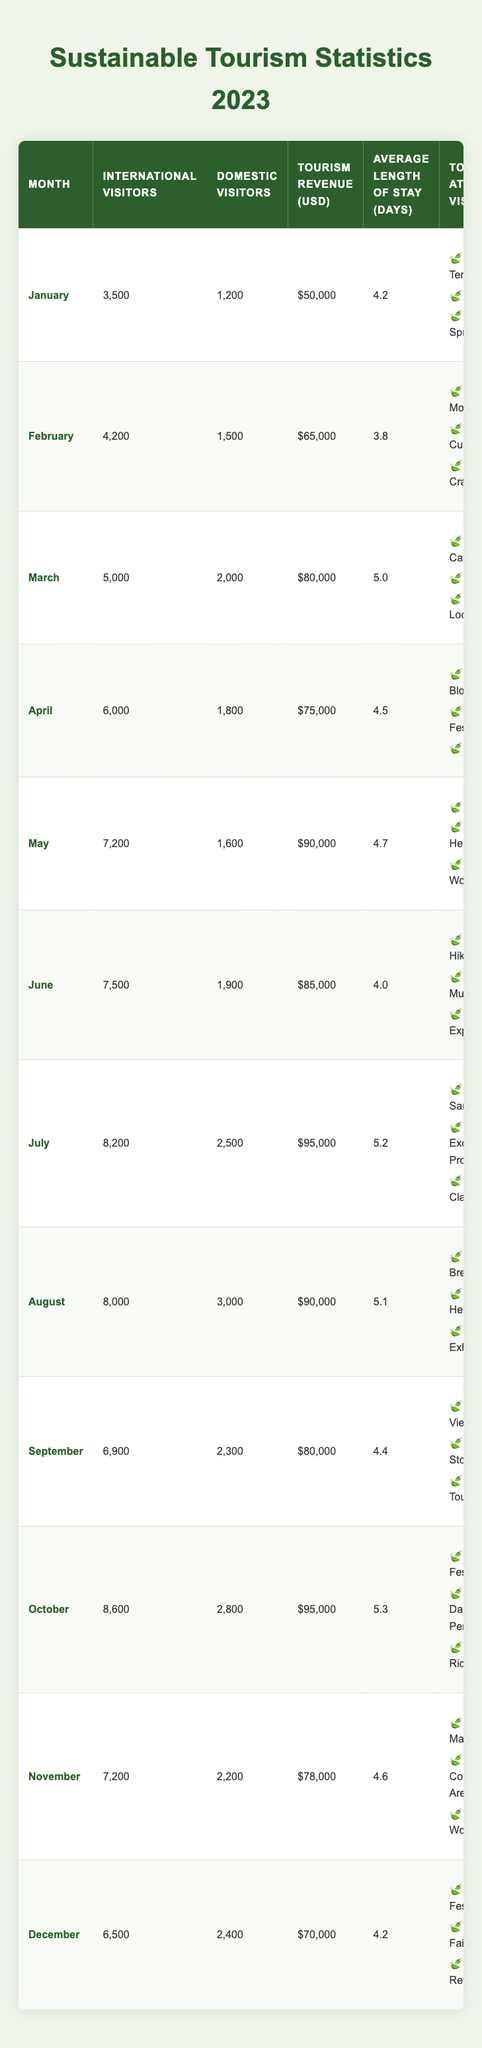What month had the highest number of international visitors? From the table, we compare the number of international visitors for each month. The highest value is found in October with 8,600 visitors.
Answer: October What is the total tourism revenue generated from January to March? We sum the tourism revenue for January ($50,000), February ($65,000), and March ($80,000). Total revenue = 50,000 + 65,000 + 80,000 = $195,000.
Answer: $195,000 Did more domestic visitors come in July compared to June? By examining the table, July had 2,500 domestic visitors and June had 1,900. Since 2,500 is greater than 1,900, the answer is yes.
Answer: Yes Which month experienced the least average length of stay? The average length of stay for each month shows that February has the lowest value at 3.8 days.
Answer: February What is the difference in international visitors between May and August? We look at the international visitors in May (7,200) and August (8,000). The difference is 8,000 - 7,200 = 800 visitors.
Answer: 800 How many more international visitors were recorded in October than in January? January had 3,500 international visitors, and October had 8,600. We calculate the difference: 8,600 - 3,500 = 5,100 visitors more in October.
Answer: 5,100 Which month had the highest tourism revenue and what was the amount? Comparing the tourism revenue, both October and July had the highest value at $95,000.
Answer: $95,000 What was the average number of international visitors from June to September? We sum the international visitors from June (7,500), July (8,200), August (8,000), and September (6,900), giving a total of 30,600. There are four months, so we divide: 30,600 / 4 = 7,650.
Answer: 7,650 In which month did visitors spend the longest in the community? By checking the average length of stay for each month, July had the longest average stay at 5.2 days.
Answer: July How many domestic visitors were there in November? Referring to the table, November had 2,200 domestic visitors listed.
Answer: 2,200 